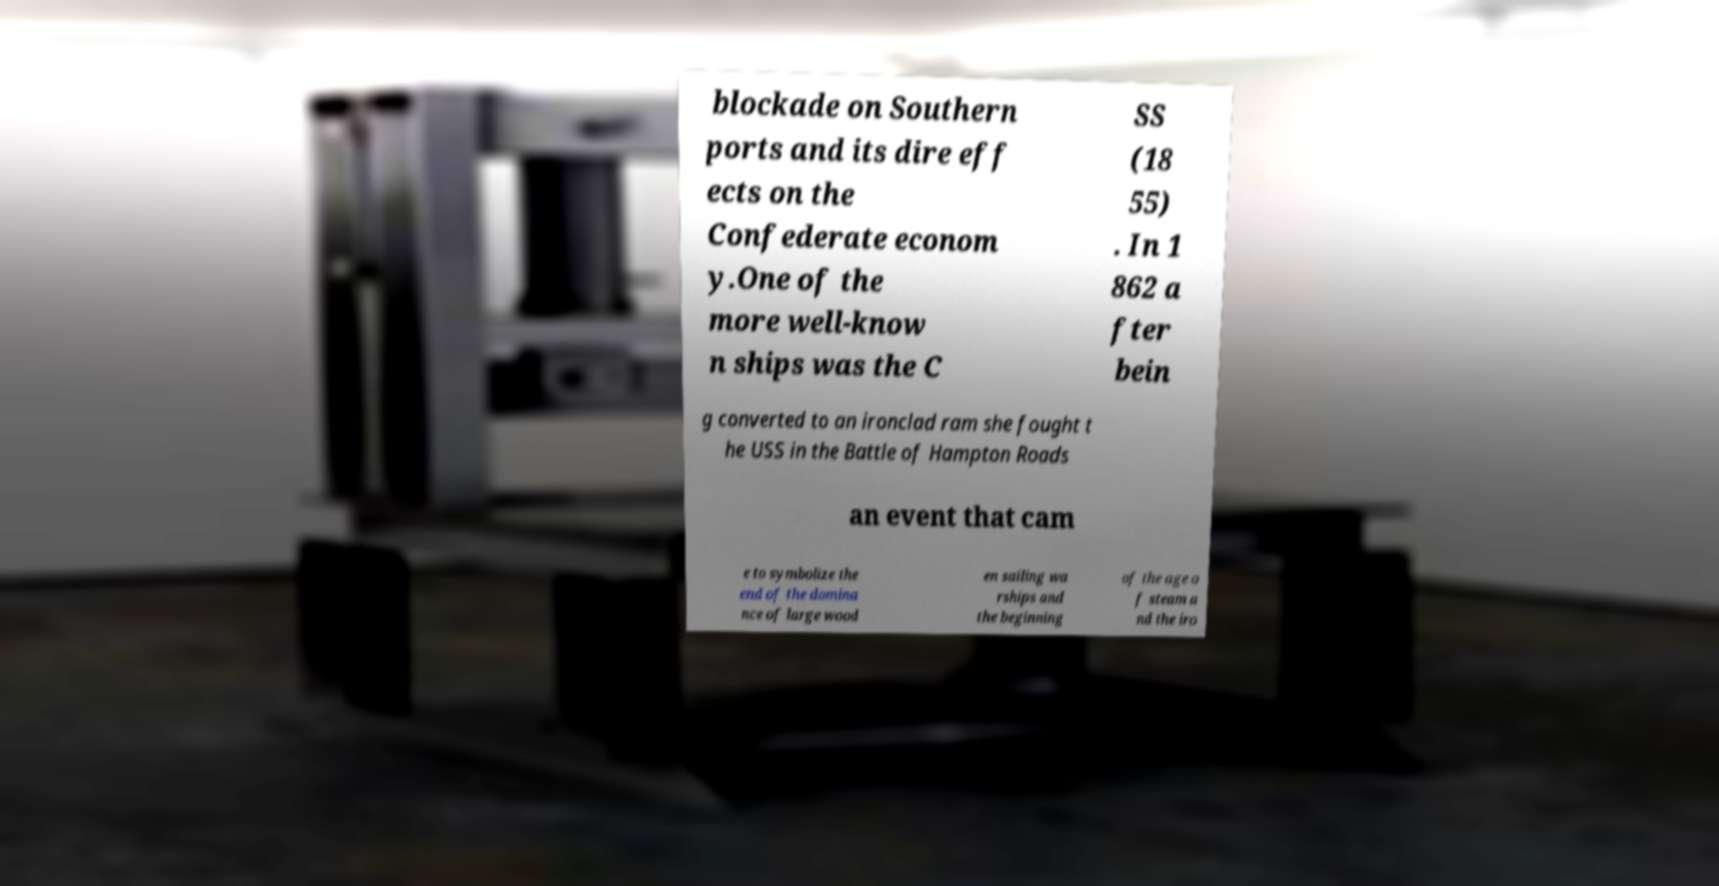I need the written content from this picture converted into text. Can you do that? blockade on Southern ports and its dire eff ects on the Confederate econom y.One of the more well-know n ships was the C SS (18 55) . In 1 862 a fter bein g converted to an ironclad ram she fought t he USS in the Battle of Hampton Roads an event that cam e to symbolize the end of the domina nce of large wood en sailing wa rships and the beginning of the age o f steam a nd the iro 